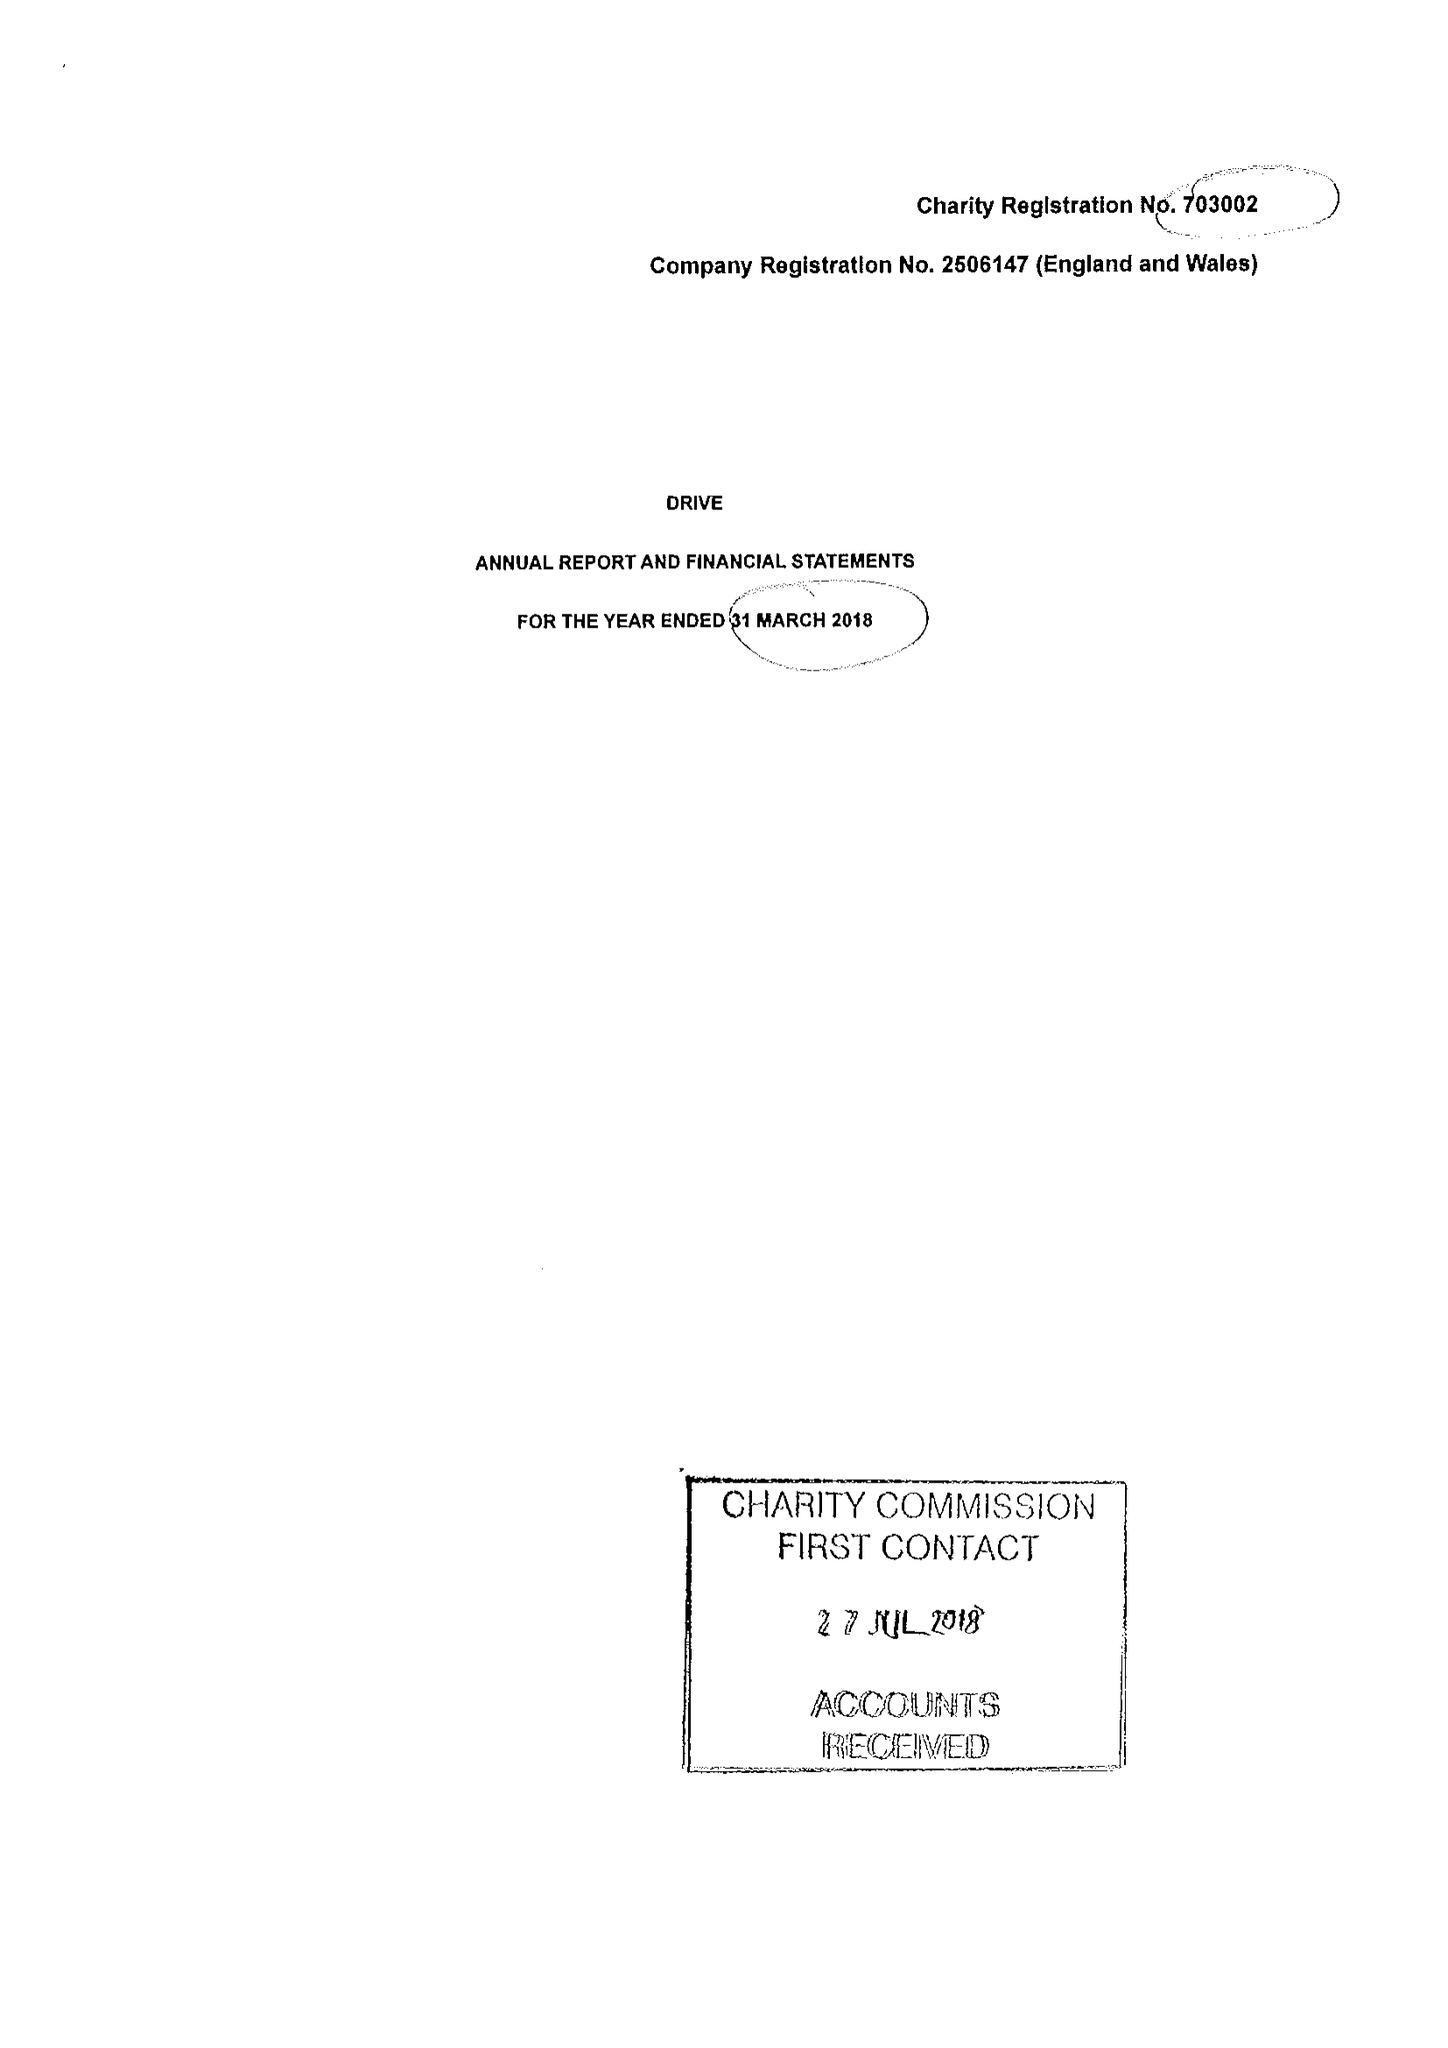What is the value for the income_annually_in_british_pounds?
Answer the question using a single word or phrase. 14749431.00 